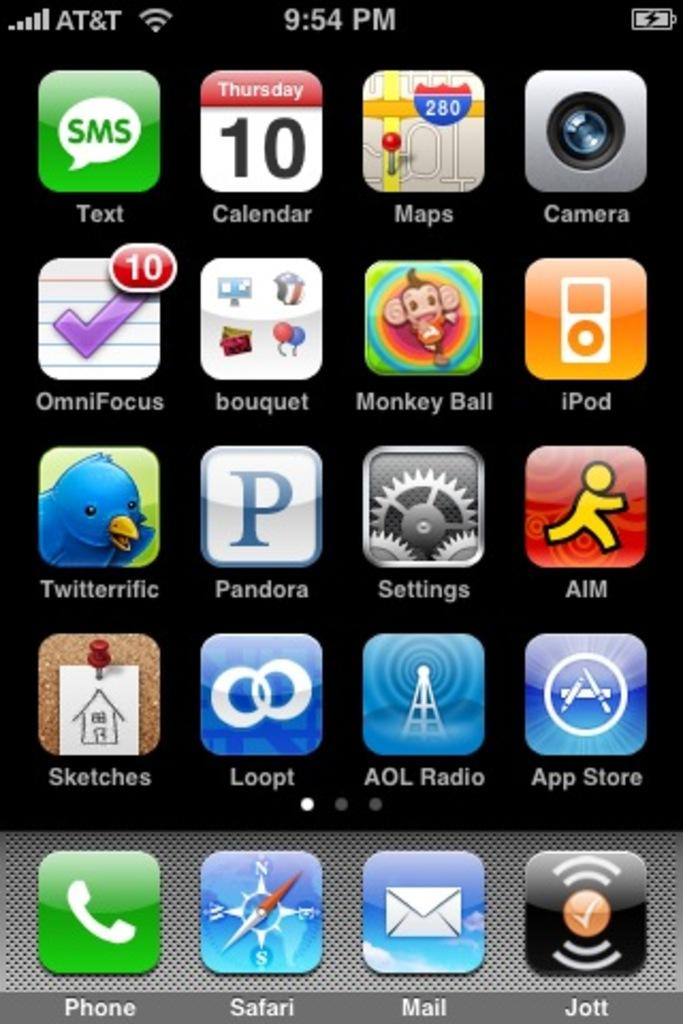<image>
Write a terse but informative summary of the picture. A phone screen with a Monkey Ball app on it. 